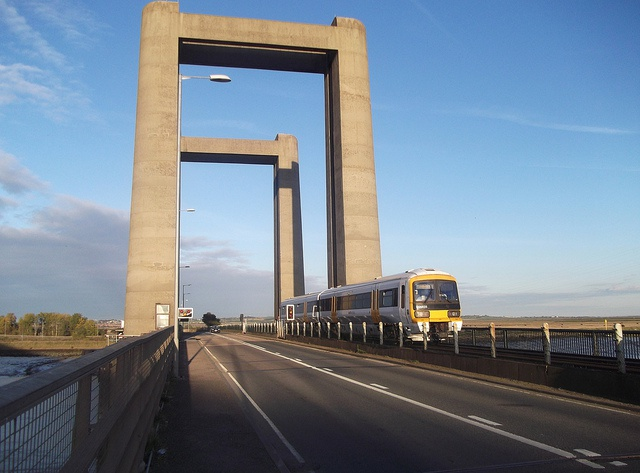Describe the objects in this image and their specific colors. I can see train in darkgray, black, and gray tones and car in darkgray, gray, and black tones in this image. 